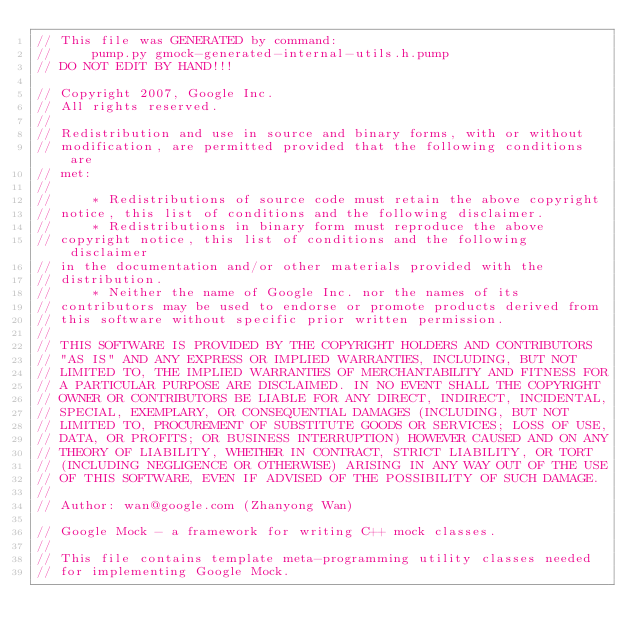<code> <loc_0><loc_0><loc_500><loc_500><_C_>// This file was GENERATED by command:
//     pump.py gmock-generated-internal-utils.h.pump
// DO NOT EDIT BY HAND!!!

// Copyright 2007, Google Inc.
// All rights reserved.
//
// Redistribution and use in source and binary forms, with or without
// modification, are permitted provided that the following conditions are
// met:
//
//     * Redistributions of source code must retain the above copyright
// notice, this list of conditions and the following disclaimer.
//     * Redistributions in binary form must reproduce the above
// copyright notice, this list of conditions and the following disclaimer
// in the documentation and/or other materials provided with the
// distribution.
//     * Neither the name of Google Inc. nor the names of its
// contributors may be used to endorse or promote products derived from
// this software without specific prior written permission.
//
// THIS SOFTWARE IS PROVIDED BY THE COPYRIGHT HOLDERS AND CONTRIBUTORS
// "AS IS" AND ANY EXPRESS OR IMPLIED WARRANTIES, INCLUDING, BUT NOT
// LIMITED TO, THE IMPLIED WARRANTIES OF MERCHANTABILITY AND FITNESS FOR
// A PARTICULAR PURPOSE ARE DISCLAIMED. IN NO EVENT SHALL THE COPYRIGHT
// OWNER OR CONTRIBUTORS BE LIABLE FOR ANY DIRECT, INDIRECT, INCIDENTAL,
// SPECIAL, EXEMPLARY, OR CONSEQUENTIAL DAMAGES (INCLUDING, BUT NOT
// LIMITED TO, PROCUREMENT OF SUBSTITUTE GOODS OR SERVICES; LOSS OF USE,
// DATA, OR PROFITS; OR BUSINESS INTERRUPTION) HOWEVER CAUSED AND ON ANY
// THEORY OF LIABILITY, WHETHER IN CONTRACT, STRICT LIABILITY, OR TORT
// (INCLUDING NEGLIGENCE OR OTHERWISE) ARISING IN ANY WAY OUT OF THE USE
// OF THIS SOFTWARE, EVEN IF ADVISED OF THE POSSIBILITY OF SUCH DAMAGE.
//
// Author: wan@google.com (Zhanyong Wan)

// Google Mock - a framework for writing C++ mock classes.
//
// This file contains template meta-programming utility classes needed
// for implementing Google Mock.
</code> 